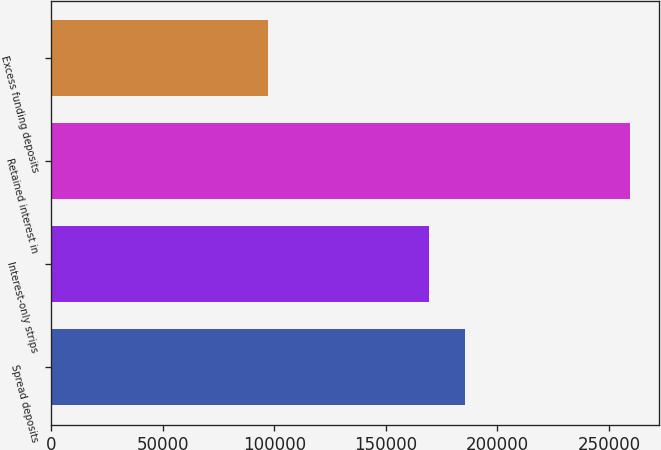<chart> <loc_0><loc_0><loc_500><loc_500><bar_chart><fcel>Spread deposits<fcel>Interest-only strips<fcel>Retained interest in<fcel>Excess funding deposits<nl><fcel>185491<fcel>169241<fcel>259612<fcel>97110<nl></chart> 